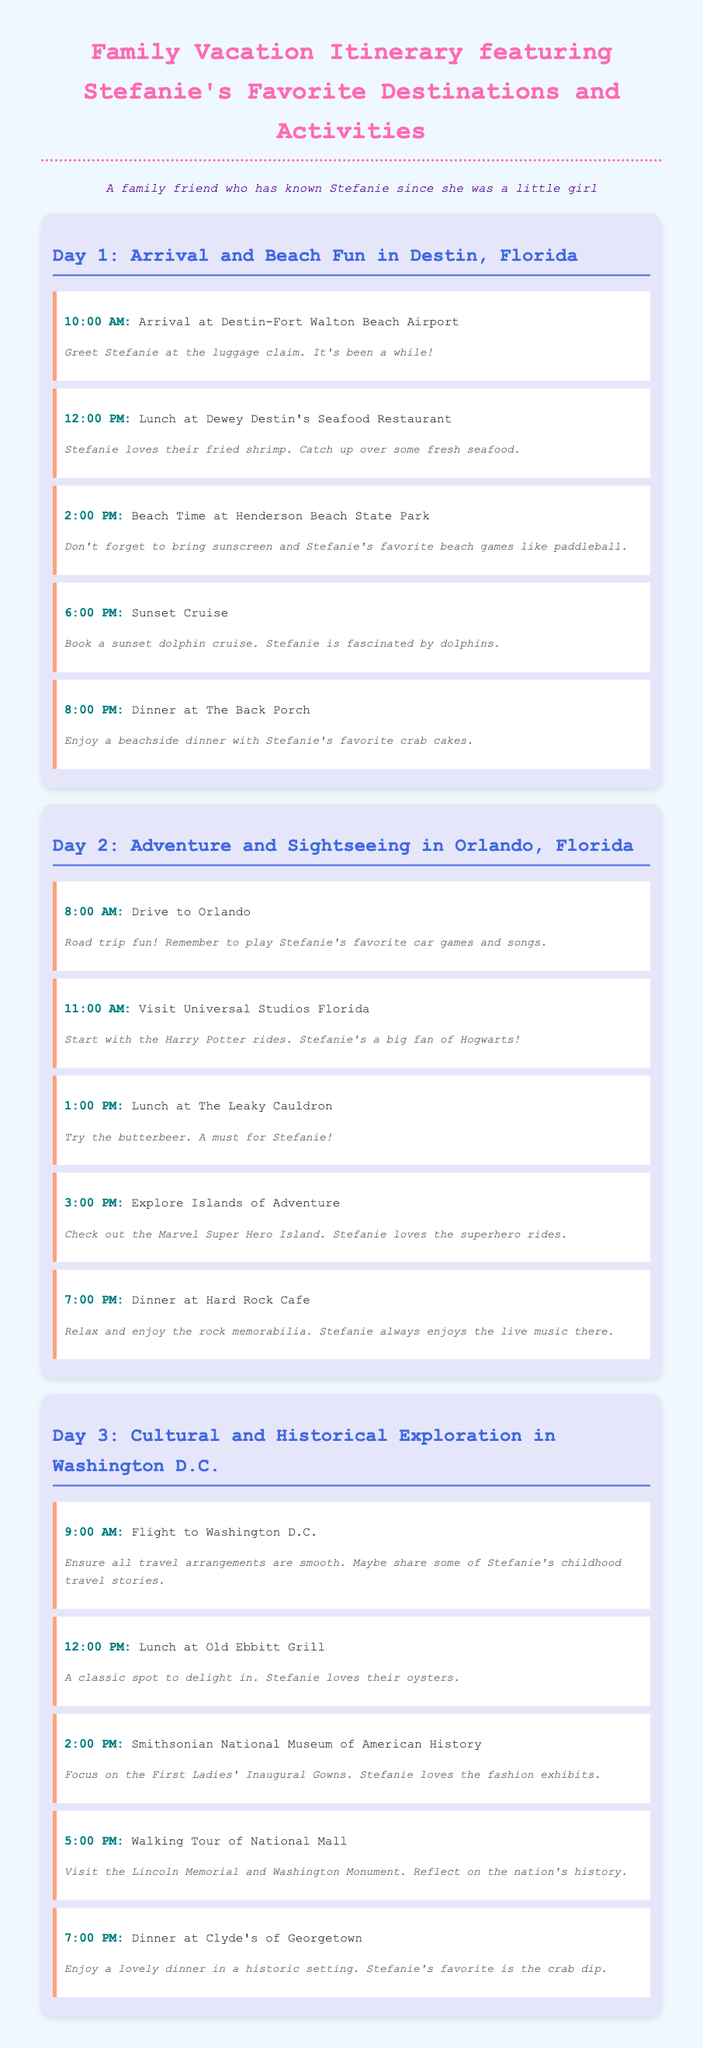What is the first activity on Day 1? The first activity is described as the arrival at the airport at 10:00 AM.
Answer: Arrival at Destin-Fort Walton Beach Airport What time is the sunset cruise scheduled for Day 1? The sunset cruise is mentioned to take place at 6:00 PM on Day 1.
Answer: 6:00 PM Which restaurant does Stefanie enjoy for lunch in Orlando? The restaurant for lunch on Day 2 is specifically mentioned, which is The Leaky Cauldron.
Answer: The Leaky Cauldron What activity does Stefanie love to do at Henderson Beach State Park? The document notes that Stefanie loves playing beach games like paddleball at Henderson Beach State Park.
Answer: paddleball What is the last activity of Day 3? The last activity mentioned for Day 3 is dinner at Clyde's of Georgetown at 7:00 PM.
Answer: Dinner at Clyde's of Georgetown How many days are planned in the itinerary? The document outlines an itinerary for three days of activities, each with specific details.
Answer: 3 days What dish is Stefanie's favorite at Old Ebbitt Grill? The document states that Stefanie loves the oysters at Old Ebbitt Grill for lunch on Day 3.
Answer: oysters What theme park does Stefanie visit on Day 2? The document mentions that Stefanie visits Universal Studios Florida during Day 2.
Answer: Universal Studios Florida What time does the family arrive in Destin, Florida? The arrival time is specified for 10:00 AM on Day 1.
Answer: 10:00 AM 